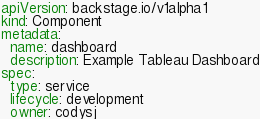Convert code to text. <code><loc_0><loc_0><loc_500><loc_500><_YAML_>apiVersion: backstage.io/v1alpha1
kind: Component
metadata:
  name: dashboard
  description: Example Tableau Dashboard
spec:
  type: service
  lifecycle: development
  owner: codysj
</code> 